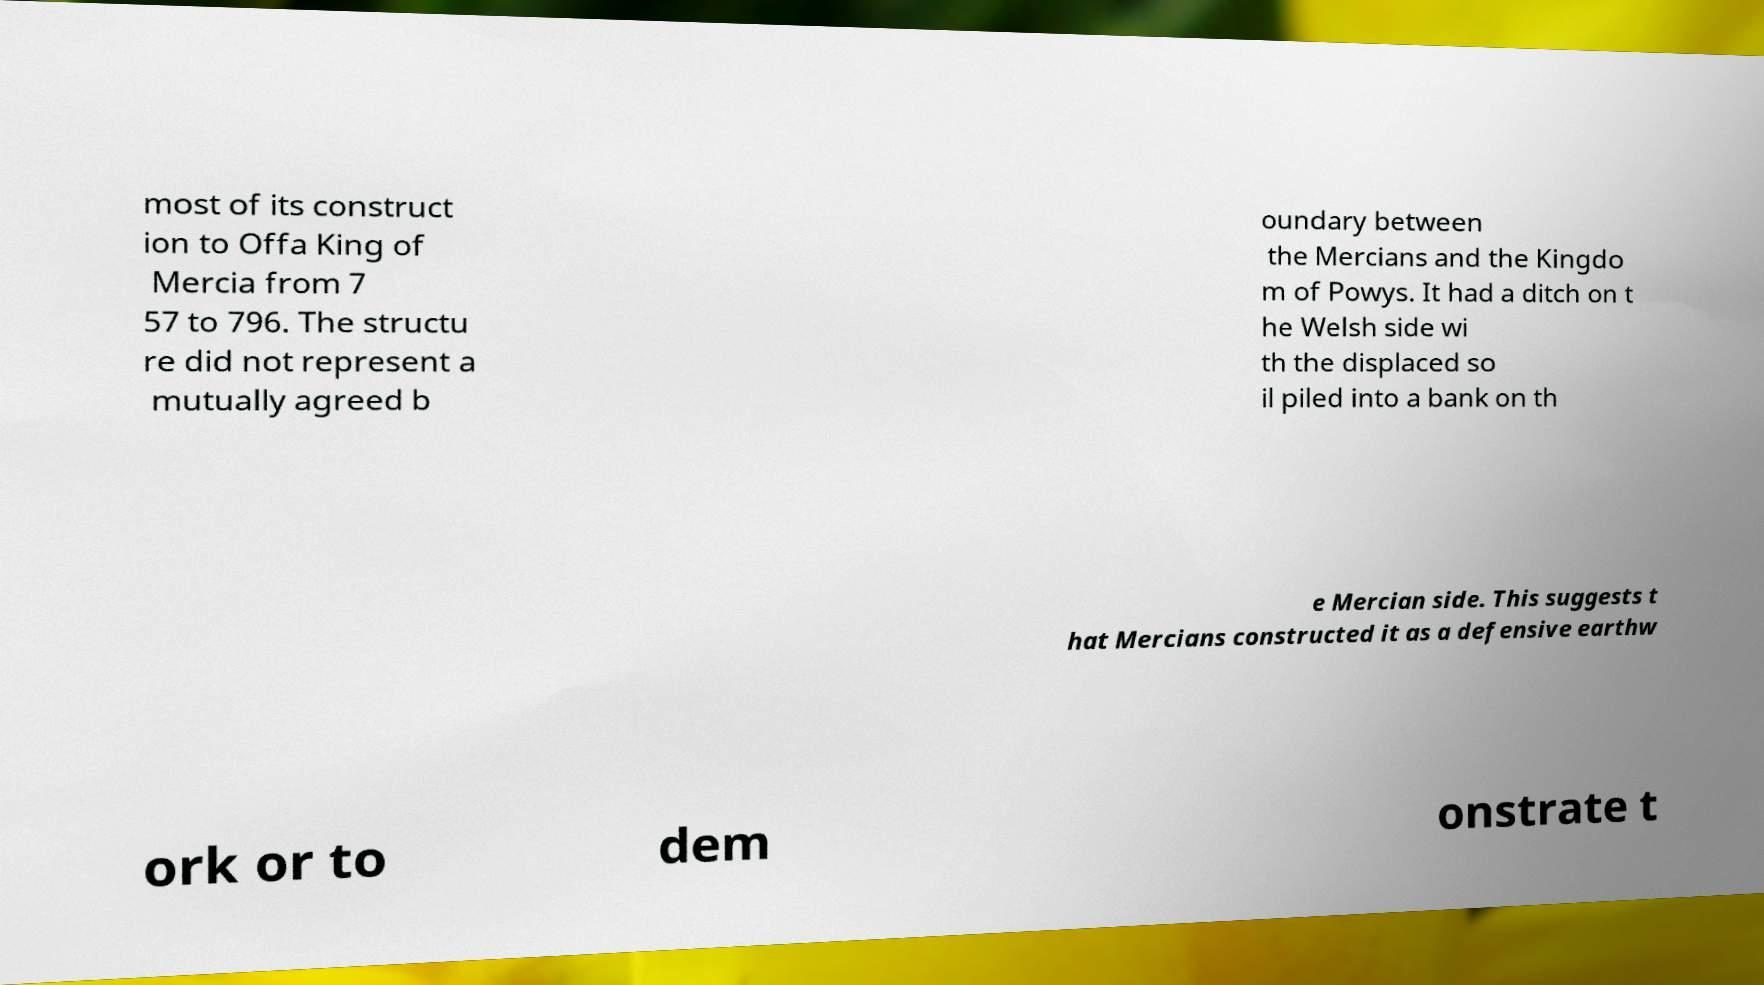I need the written content from this picture converted into text. Can you do that? most of its construct ion to Offa King of Mercia from 7 57 to 796. The structu re did not represent a mutually agreed b oundary between the Mercians and the Kingdo m of Powys. It had a ditch on t he Welsh side wi th the displaced so il piled into a bank on th e Mercian side. This suggests t hat Mercians constructed it as a defensive earthw ork or to dem onstrate t 